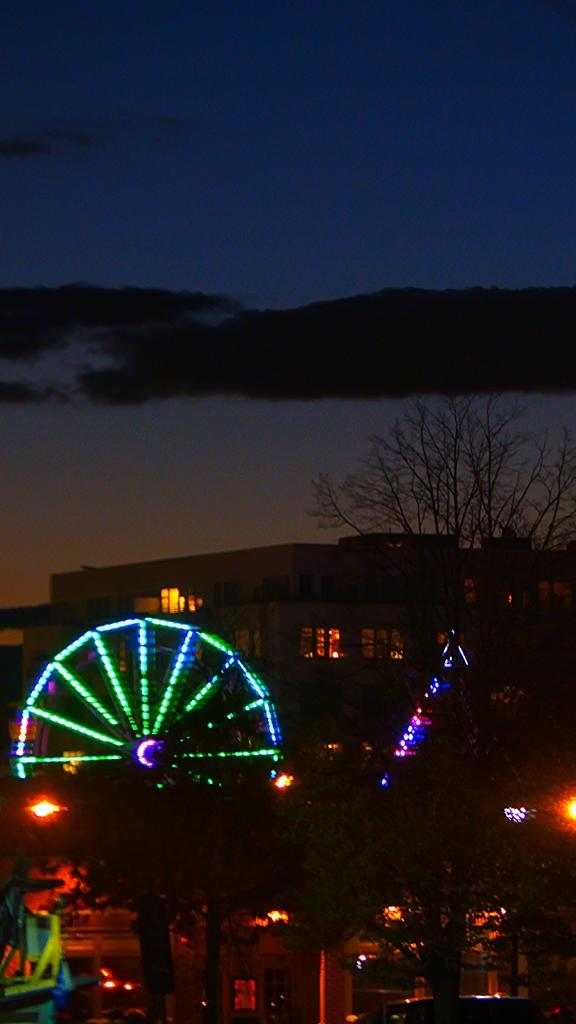What type of structures can be seen in the image? There are buildings in the image. What other natural elements are present in the image? There are trees in the image. Are there any artificial light sources visible in the image? Yes, there are lights in the image. What type of transportation-related object is present in the image? There is a joint wheel in the image. What can be seen in the background of the image? The sky is visible in the background of the image. Can you see any steam coming from the buildings in the image? There is no steam visible in the image. What type of utensil is being used by the bee in the image? There are no bees present in the image, so this question cannot be answered. 